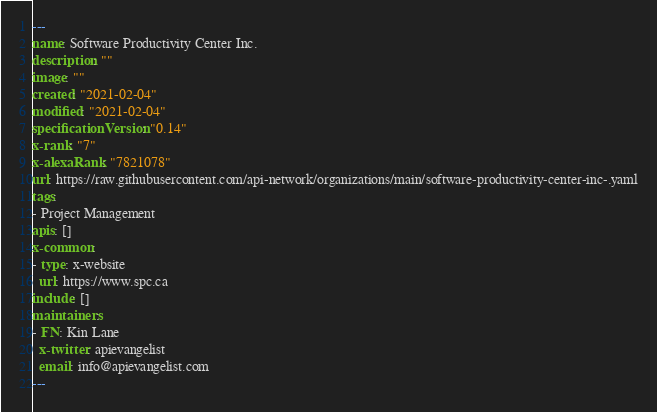Convert code to text. <code><loc_0><loc_0><loc_500><loc_500><_YAML_>---
name: Software Productivity Center Inc.
description: ""
image: ""
created: "2021-02-04"
modified: "2021-02-04"
specificationVersion: "0.14"
x-rank: "7"
x-alexaRank: "7821078"
url: https://raw.githubusercontent.com/api-network/organizations/main/software-productivity-center-inc-.yaml
tags:
- Project Management
apis: []
x-common:
- type: x-website
  url: https://www.spc.ca
include: []
maintainers:
- FN: Kin Lane
  x-twitter: apievangelist
  email: info@apievangelist.com
---</code> 